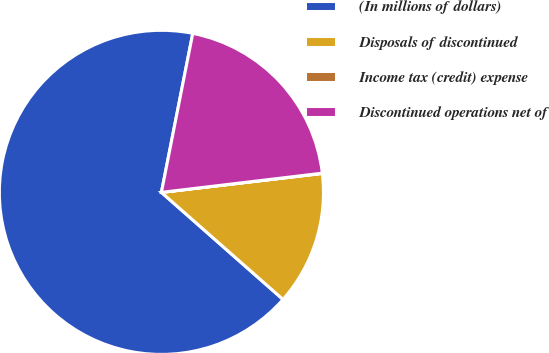Convert chart. <chart><loc_0><loc_0><loc_500><loc_500><pie_chart><fcel>(In millions of dollars)<fcel>Disposals of discontinued<fcel>Income tax (credit) expense<fcel>Discontinued operations net of<nl><fcel>66.61%<fcel>13.35%<fcel>0.03%<fcel>20.01%<nl></chart> 